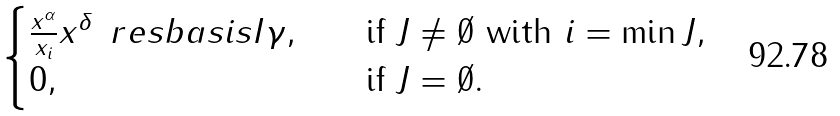<formula> <loc_0><loc_0><loc_500><loc_500>\begin{cases} \frac { x ^ { \alpha } } { x _ { i } } x ^ { \delta } \, \ r e s b a s i s { I } { \gamma } , & \quad \text {if } J \neq \emptyset \text { with } i = \min J , \\ 0 , & \quad \text {if } J = \emptyset . \end{cases}</formula> 